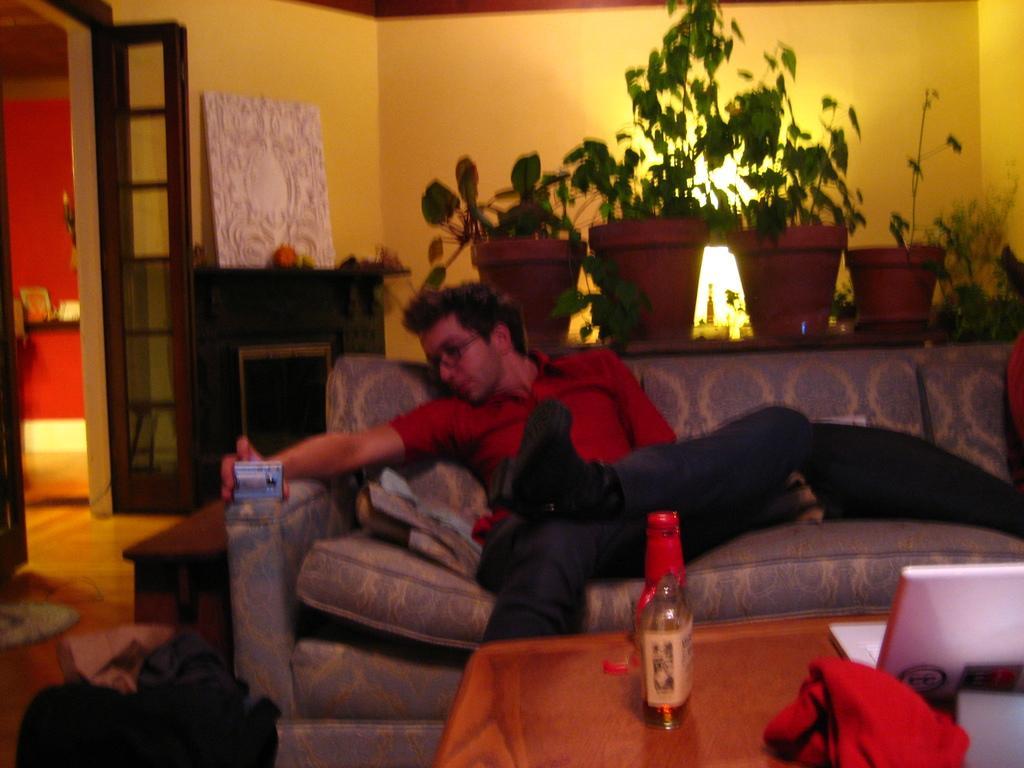How would you summarize this image in a sentence or two? This picture is a man sitting on the couch, holding some object with his right hand and there is also a table in front of him with a beer bottle. In the background there is a wall, light and some plants. 